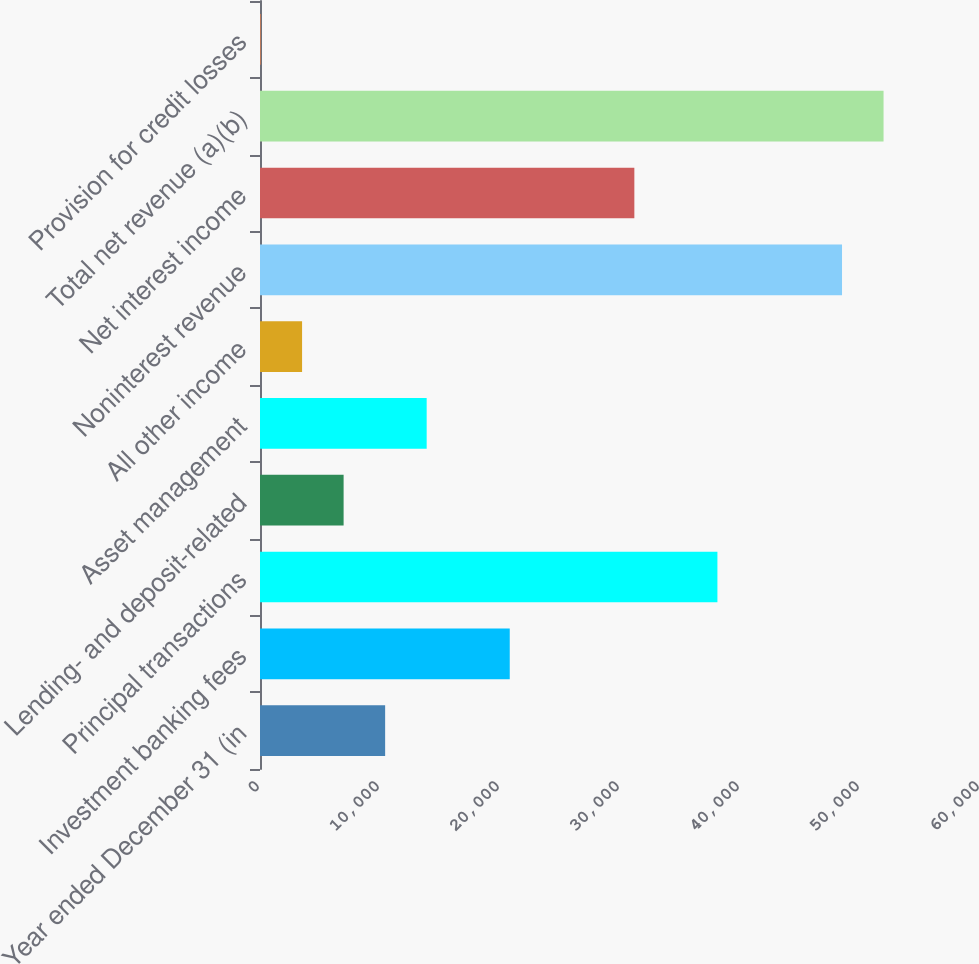Convert chart. <chart><loc_0><loc_0><loc_500><loc_500><bar_chart><fcel>Year ended December 31 (in<fcel>Investment banking fees<fcel>Principal transactions<fcel>Lending- and deposit-related<fcel>Asset management<fcel>All other income<fcel>Noninterest revenue<fcel>Net interest income<fcel>Total net revenue (a)(b)<fcel>Provision for credit losses<nl><fcel>10428.6<fcel>20812.2<fcel>38118.2<fcel>6967.4<fcel>13889.8<fcel>3506.2<fcel>48501.8<fcel>31195.8<fcel>51963<fcel>45<nl></chart> 